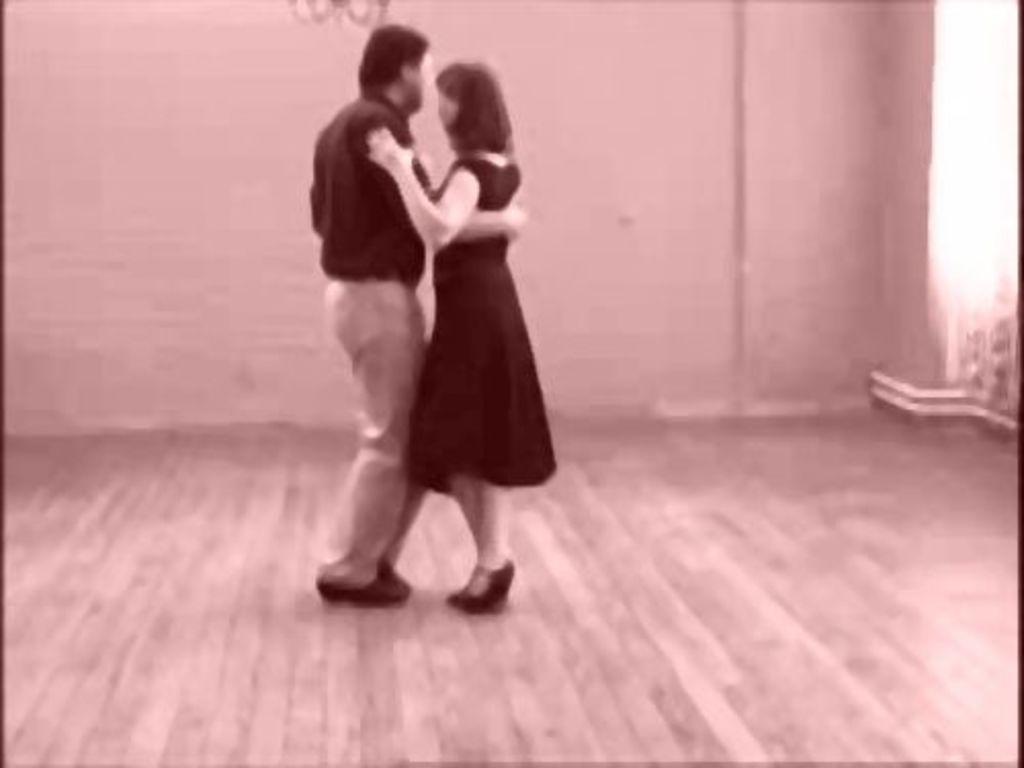How would you summarize this image in a sentence or two? In this picture we can see a man wearing black color shirt and cream pant dancing with a woman wearing a black top. On the bottom there is a wooden flooring. 